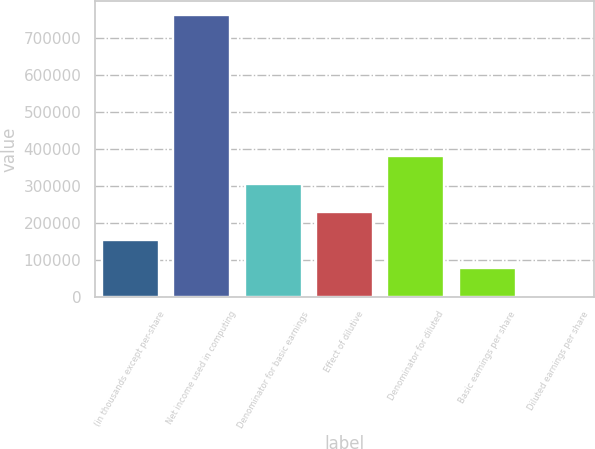Convert chart to OTSL. <chart><loc_0><loc_0><loc_500><loc_500><bar_chart><fcel>(in thousands except per-share<fcel>Net income used in computing<fcel>Denominator for basic earnings<fcel>Effect of dilutive<fcel>Denominator for diluted<fcel>Basic earnings per share<fcel>Diluted earnings per share<nl><fcel>152188<fcel>760928<fcel>304373<fcel>228280<fcel>380465<fcel>76095.1<fcel>2.5<nl></chart> 